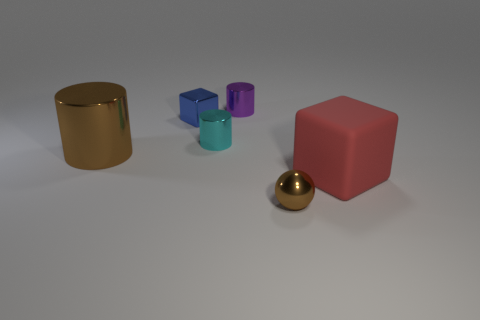Subtract all cyan shiny cylinders. How many cylinders are left? 2 Add 3 small metallic things. How many objects exist? 9 Subtract all cubes. How many objects are left? 4 Subtract all yellow cylinders. Subtract all red cubes. How many cylinders are left? 3 Subtract all green rubber cubes. Subtract all cyan metal things. How many objects are left? 5 Add 3 big shiny cylinders. How many big shiny cylinders are left? 4 Add 4 large green metallic cylinders. How many large green metallic cylinders exist? 4 Subtract 0 brown blocks. How many objects are left? 6 